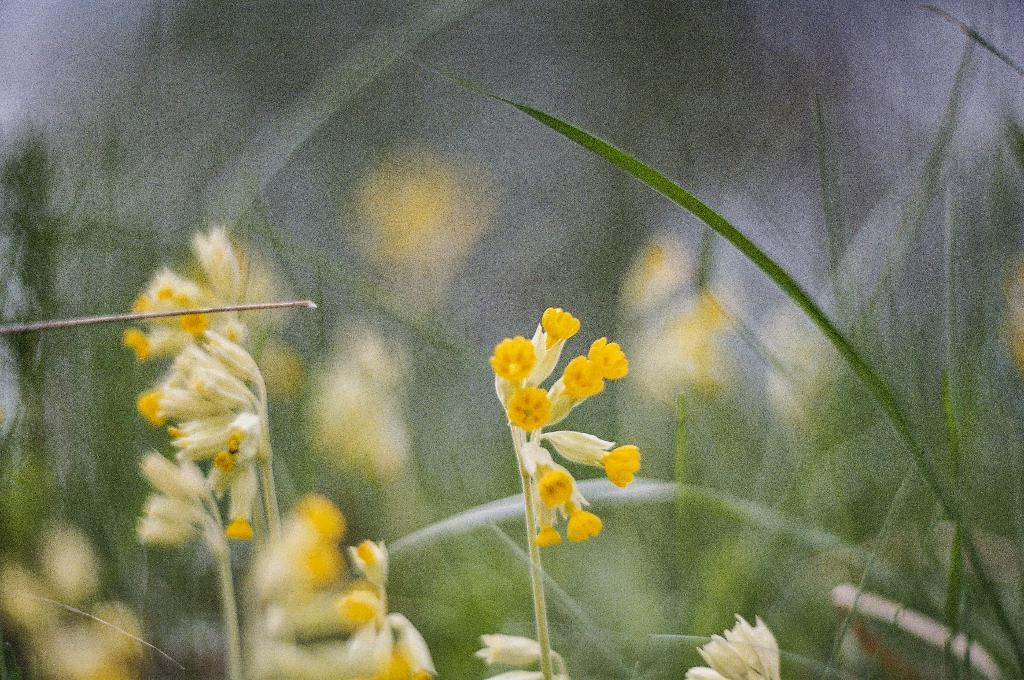What type of plants can be seen in the image? There are flowers in the image. What color are the flowers? The flowers are yellow in color. What else can be seen in the background of the image? There are leaves in the background of the image. What type of interest does the flower have in the image? The image does not depict any interest or emotions, as it is a still image of flowers. 